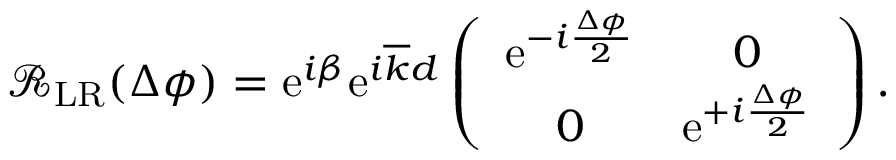Convert formula to latex. <formula><loc_0><loc_0><loc_500><loc_500>\begin{array} { r } { \mathcal { R } _ { L R } ( \Delta \phi ) = e ^ { i \beta } e ^ { i \overline { k } d } \left ( \begin{array} { c c } { e ^ { - i \frac { \Delta \phi } { 2 } } } & { 0 } \\ { 0 } & { e ^ { + i \frac { \Delta \phi } { 2 } } } \end{array} \right ) . } \end{array}</formula> 